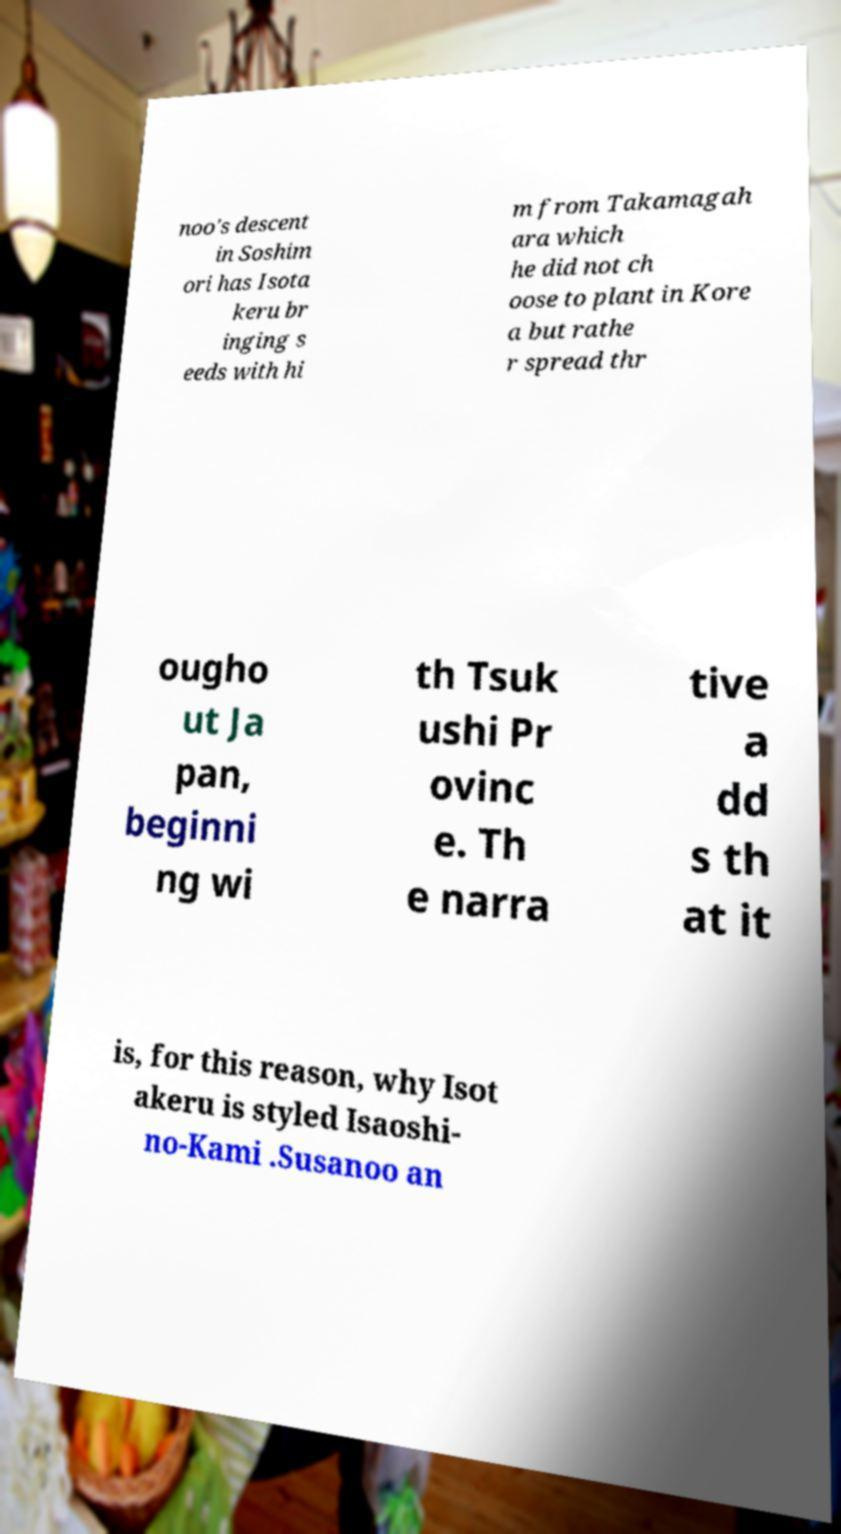Can you accurately transcribe the text from the provided image for me? noo's descent in Soshim ori has Isota keru br inging s eeds with hi m from Takamagah ara which he did not ch oose to plant in Kore a but rathe r spread thr ougho ut Ja pan, beginni ng wi th Tsuk ushi Pr ovinc e. Th e narra tive a dd s th at it is, for this reason, why Isot akeru is styled Isaoshi- no-Kami .Susanoo an 